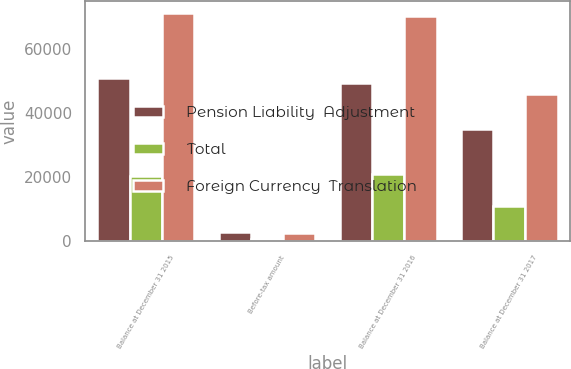Convert chart. <chart><loc_0><loc_0><loc_500><loc_500><stacked_bar_chart><ecel><fcel>Balance at December 31 2015<fcel>Before-tax amount<fcel>Balance at December 31 2016<fcel>Balance at December 31 2017<nl><fcel>Pension Liability  Adjustment<fcel>50905<fcel>3045<fcel>49200<fcel>35041<nl><fcel>Total<fcel>20273<fcel>602<fcel>20875<fcel>10915<nl><fcel>Foreign Currency  Translation<fcel>71178<fcel>2443<fcel>70075<fcel>45956<nl></chart> 